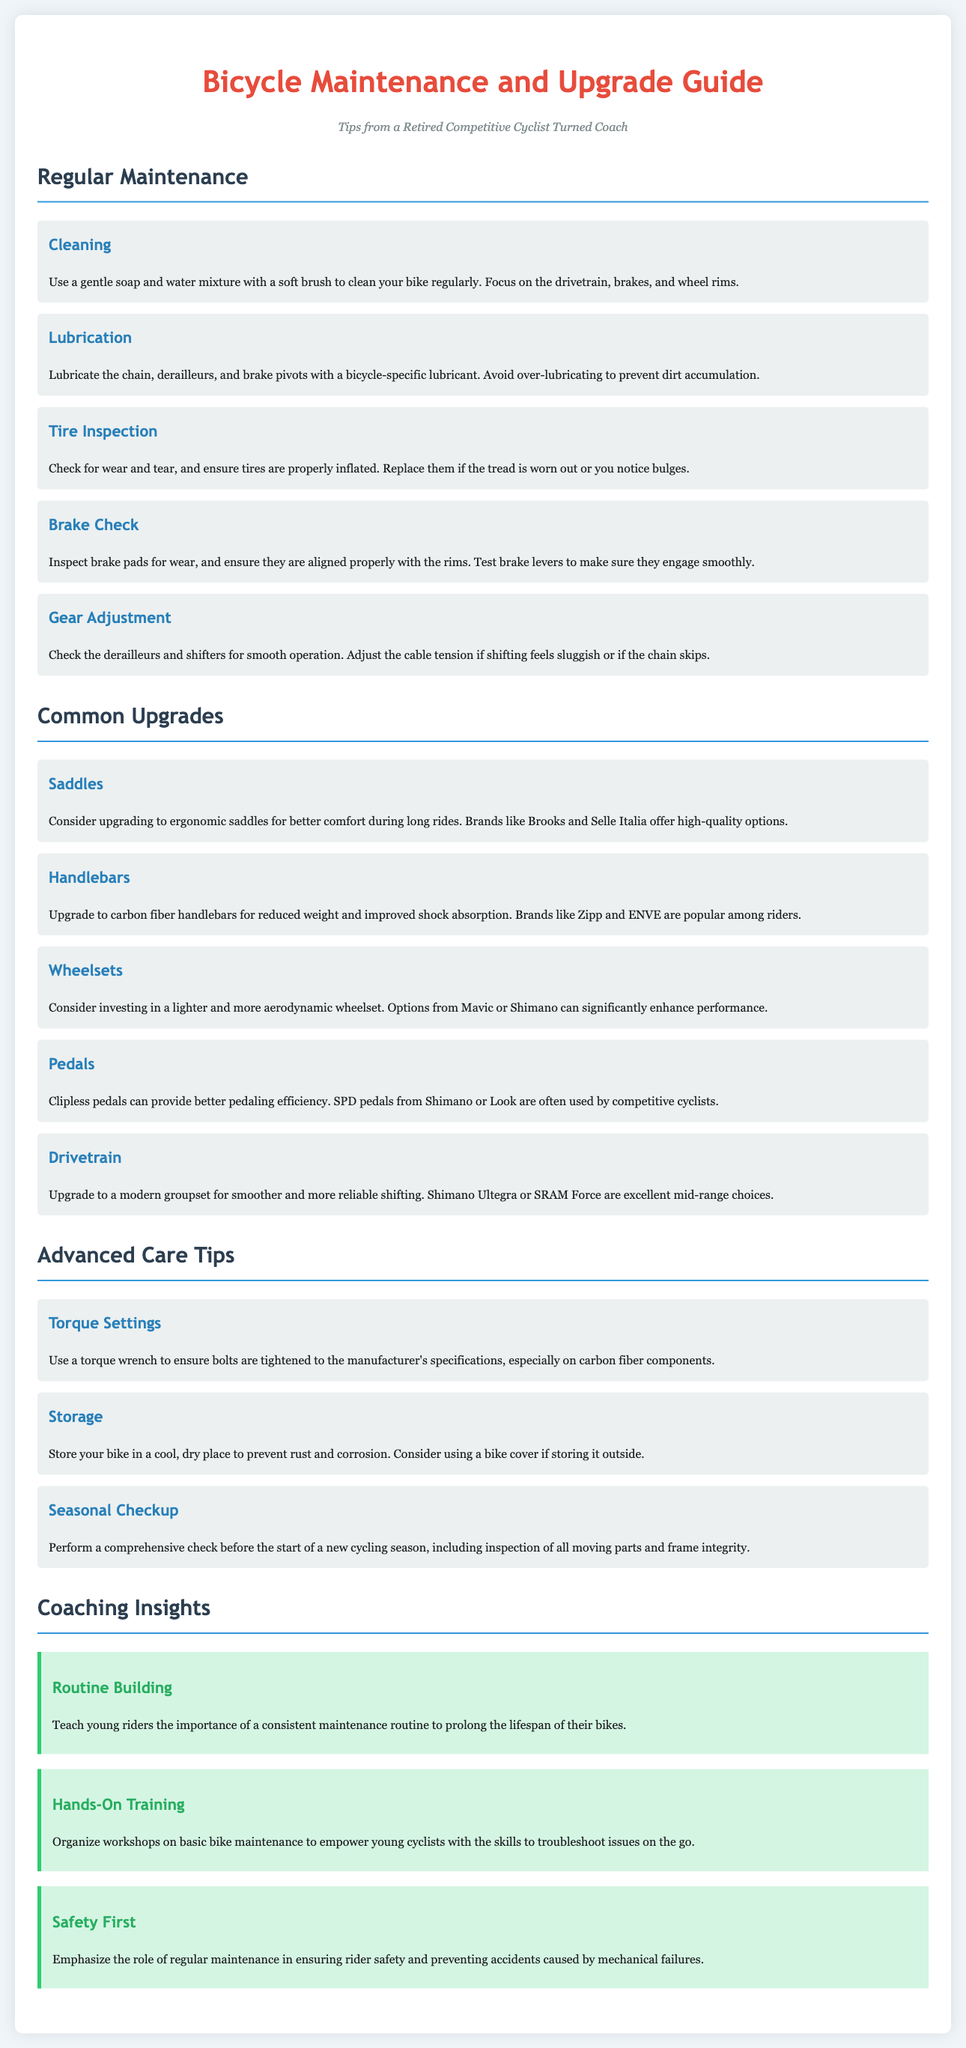What is the first section in the guide? The first section listed in the guide is "Regular Maintenance."
Answer: Regular Maintenance How often should you check tire pressure? While the document doesn't specify a frequency, it suggests checking for wear and ensuring proper inflation.
Answer: Regularly Which brand is suggested for upgrading saddles? The guide recommends brands like Brooks and Selle Italia for ergonomic saddles.
Answer: Brooks What is a recommended upgrade for handlebars? The guide suggests upgrading to carbon fiber handlebars for better performance.
Answer: Carbon fiber handlebars What should be used to ensure proper torque settings? A torque wrench is recommended for ensuring bolts are tightened according to specifications.
Answer: Torque wrench How does regular maintenance contribute to cycling? Regular maintenance plays a role in ensuring rider safety and preventing mechanical failures.
Answer: Rider safety What component should be lubricated regularly? The guide advises lubricating the chain to maintain performance.
Answer: Chain What is emphasized in coaching insights regarding young riders? The importance of a consistent maintenance routine is emphasized to prolong bike lifespan.
Answer: Consistent maintenance routine Which bicycle component's inspection is essential before the cycling season starts? The document mentions performing a comprehensive check on all moving parts and frame integrity.
Answer: All moving parts and frame integrity 